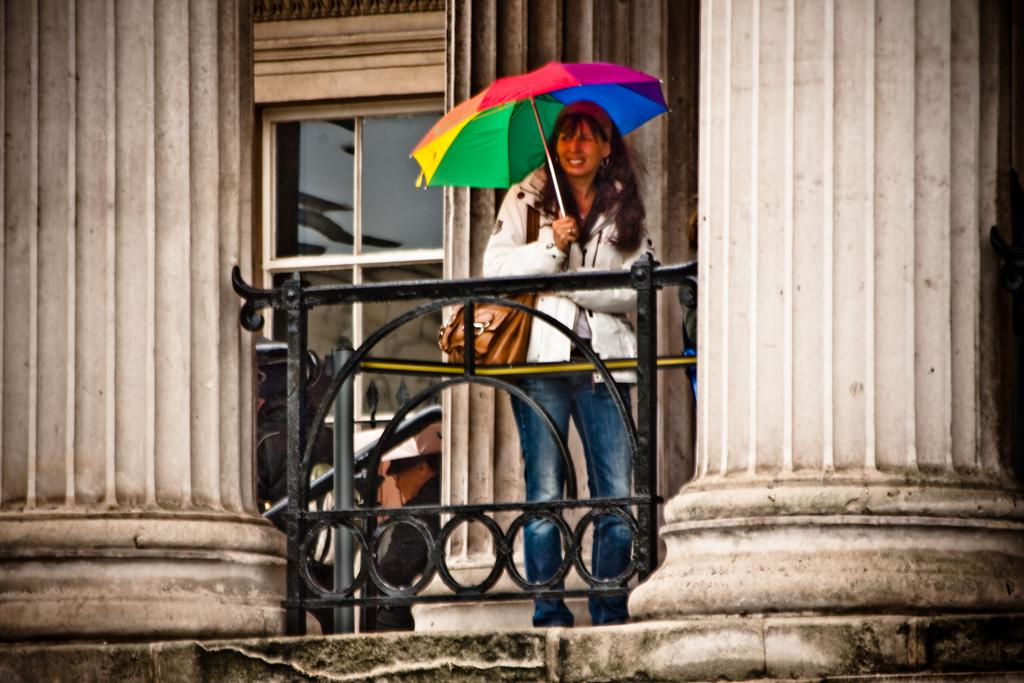Question: who is holding an umbrella?
Choices:
A. A woman.
B. A boy.
C. A man.
D. A toddler.
Answer with the letter. Answer: A Question: what kind of pants is the woman wearing?
Choices:
A. Jeans.
B. Cargo.
C. Shorts.
D. Leggings.
Answer with the letter. Answer: A Question: who holds a rainbow umbrella?
Choices:
A. The man.
B. The woman.
C. The child.
D. The old lady.
Answer with the letter. Answer: B Question: who is wearing jeans?
Choices:
A. The young man.
B. The child.
C. The woman.
D. The mom.
Answer with the letter. Answer: C Question: what is she carrying?
Choices:
A. A dog.
B. A purse.
C. A bag of groceries.
D. A card.
Answer with the letter. Answer: B Question: who is wearing a headband?
Choices:
A. The dancer.
B. The girl.
C. The woman.
D. The athlete.
Answer with the letter. Answer: C Question: what color is the woman's pants?
Choices:
A. Navy.
B. Blue.
C. Aqua.
D. Cobalt.
Answer with the letter. Answer: B Question: where is window?
Choices:
A. Over the sink.
B. Above the bed.
C. Behind woman.
D. Overlooking the terrace.
Answer with the letter. Answer: C Question: what does the lady have over her shoulder?
Choices:
A. A sweater.
B. A scarf.
C. A purse.
D. An infant.
Answer with the letter. Answer: C 